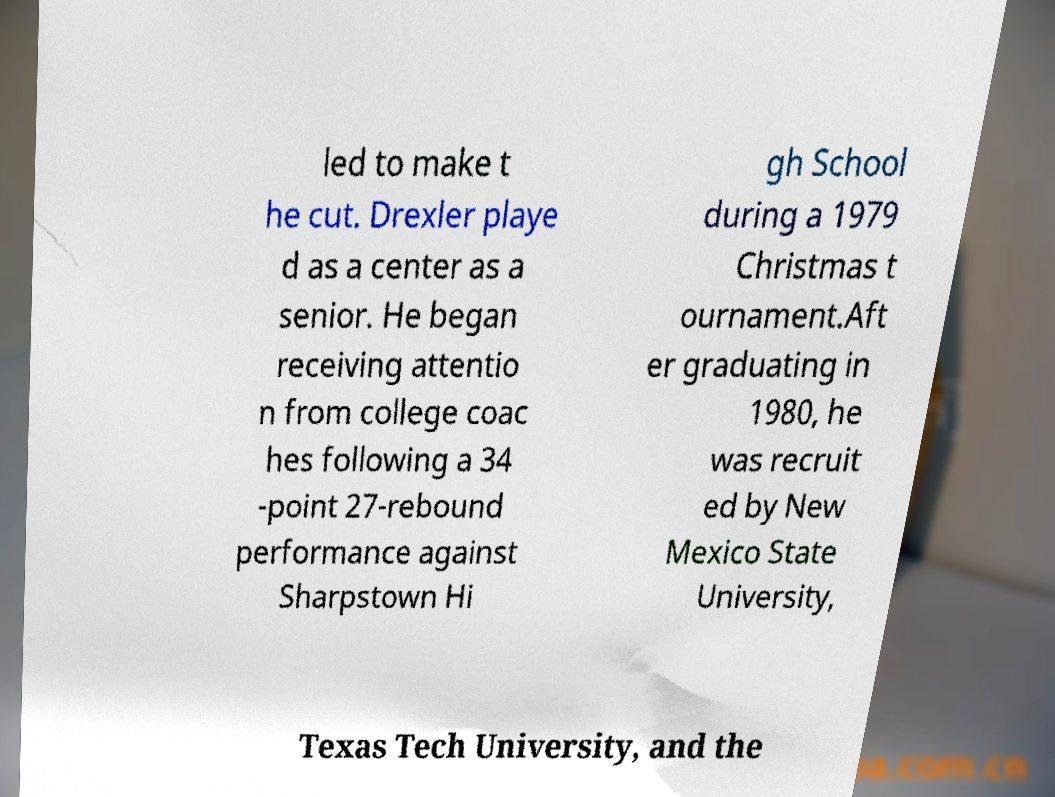I need the written content from this picture converted into text. Can you do that? led to make t he cut. Drexler playe d as a center as a senior. He began receiving attentio n from college coac hes following a 34 -point 27-rebound performance against Sharpstown Hi gh School during a 1979 Christmas t ournament.Aft er graduating in 1980, he was recruit ed by New Mexico State University, Texas Tech University, and the 